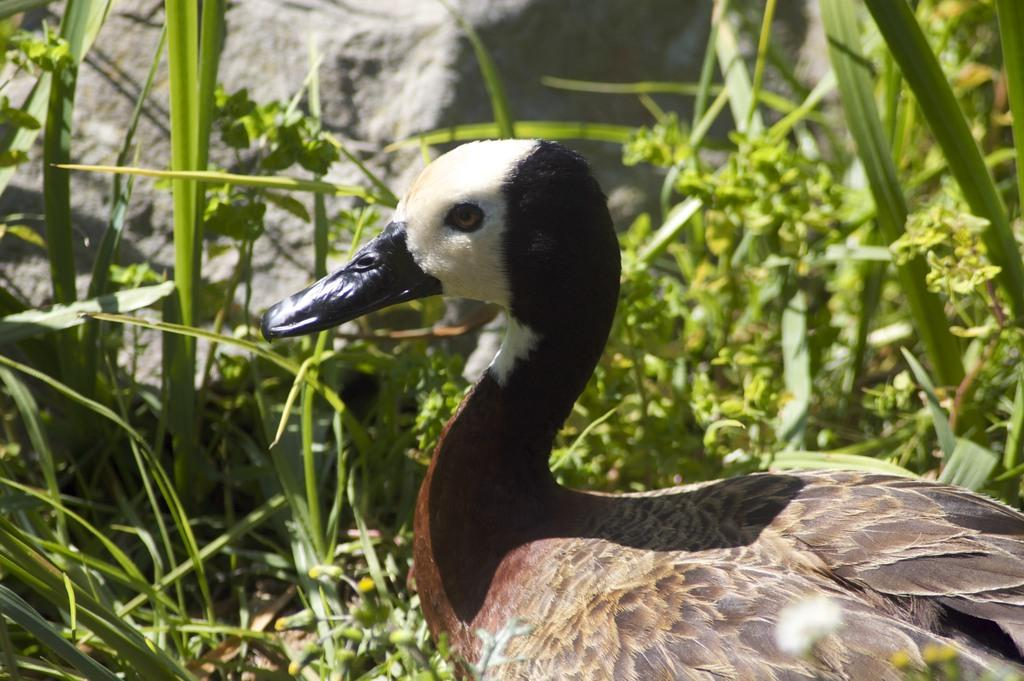What type of animal is in the image? There is a duck in the image. What other elements can be seen in the image besides the duck? There are plants visible in the image. What can be seen in the background of the image? There is a rock visible in the background of the image. Where is the cobweb located in the image? There is no cobweb present in the image. What type of material is the duck made of in the image? The duck is a living animal and not made of any material in the image. 